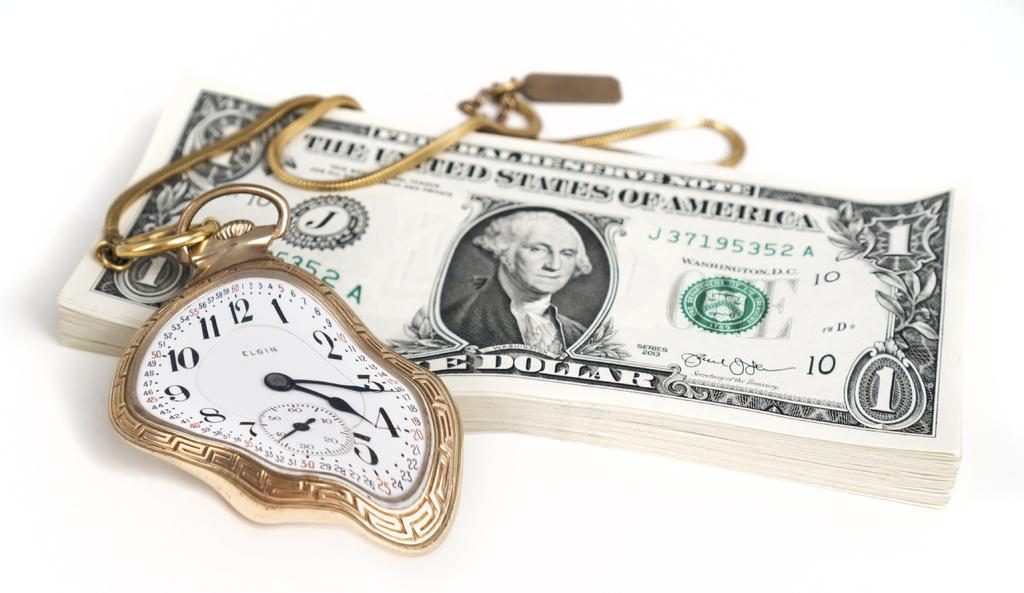<image>
Share a concise interpretation of the image provided. An Elgin pocket watch sits on a stack of one dollar bills. 